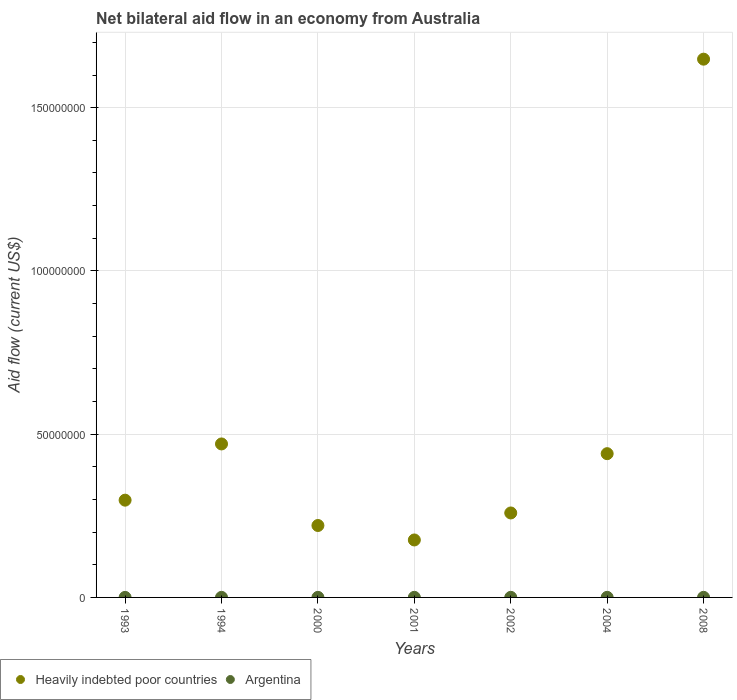How many different coloured dotlines are there?
Ensure brevity in your answer.  2. What is the net bilateral aid flow in Heavily indebted poor countries in 1993?
Provide a short and direct response. 2.98e+07. Across all years, what is the maximum net bilateral aid flow in Argentina?
Provide a short and direct response. 3.00e+04. Across all years, what is the minimum net bilateral aid flow in Heavily indebted poor countries?
Ensure brevity in your answer.  1.76e+07. In which year was the net bilateral aid flow in Argentina minimum?
Provide a short and direct response. 1993. What is the difference between the net bilateral aid flow in Argentina in 2002 and that in 2008?
Ensure brevity in your answer.  0. What is the difference between the net bilateral aid flow in Argentina in 1993 and the net bilateral aid flow in Heavily indebted poor countries in 2000?
Your response must be concise. -2.20e+07. What is the average net bilateral aid flow in Heavily indebted poor countries per year?
Keep it short and to the point. 5.02e+07. In the year 2002, what is the difference between the net bilateral aid flow in Argentina and net bilateral aid flow in Heavily indebted poor countries?
Your response must be concise. -2.58e+07. What is the ratio of the net bilateral aid flow in Heavily indebted poor countries in 2000 to that in 2001?
Make the answer very short. 1.25. Is the difference between the net bilateral aid flow in Argentina in 2000 and 2008 greater than the difference between the net bilateral aid flow in Heavily indebted poor countries in 2000 and 2008?
Offer a terse response. Yes. What is the difference between the highest and the second highest net bilateral aid flow in Heavily indebted poor countries?
Make the answer very short. 1.18e+08. What is the difference between the highest and the lowest net bilateral aid flow in Heavily indebted poor countries?
Ensure brevity in your answer.  1.47e+08. In how many years, is the net bilateral aid flow in Heavily indebted poor countries greater than the average net bilateral aid flow in Heavily indebted poor countries taken over all years?
Provide a short and direct response. 1. How many dotlines are there?
Give a very brief answer. 2. Does the graph contain any zero values?
Offer a very short reply. No. How many legend labels are there?
Provide a short and direct response. 2. How are the legend labels stacked?
Offer a terse response. Horizontal. What is the title of the graph?
Offer a terse response. Net bilateral aid flow in an economy from Australia. Does "Singapore" appear as one of the legend labels in the graph?
Your response must be concise. No. What is the Aid flow (current US$) of Heavily indebted poor countries in 1993?
Make the answer very short. 2.98e+07. What is the Aid flow (current US$) of Argentina in 1993?
Ensure brevity in your answer.  10000. What is the Aid flow (current US$) of Heavily indebted poor countries in 1994?
Give a very brief answer. 4.70e+07. What is the Aid flow (current US$) in Heavily indebted poor countries in 2000?
Provide a short and direct response. 2.20e+07. What is the Aid flow (current US$) of Argentina in 2000?
Offer a terse response. 2.00e+04. What is the Aid flow (current US$) of Heavily indebted poor countries in 2001?
Your answer should be compact. 1.76e+07. What is the Aid flow (current US$) of Heavily indebted poor countries in 2002?
Your answer should be very brief. 2.59e+07. What is the Aid flow (current US$) in Heavily indebted poor countries in 2004?
Make the answer very short. 4.40e+07. What is the Aid flow (current US$) in Heavily indebted poor countries in 2008?
Your answer should be very brief. 1.65e+08. Across all years, what is the maximum Aid flow (current US$) in Heavily indebted poor countries?
Your response must be concise. 1.65e+08. Across all years, what is the minimum Aid flow (current US$) in Heavily indebted poor countries?
Your answer should be compact. 1.76e+07. What is the total Aid flow (current US$) in Heavily indebted poor countries in the graph?
Make the answer very short. 3.51e+08. What is the total Aid flow (current US$) of Argentina in the graph?
Offer a terse response. 1.70e+05. What is the difference between the Aid flow (current US$) of Heavily indebted poor countries in 1993 and that in 1994?
Give a very brief answer. -1.72e+07. What is the difference between the Aid flow (current US$) in Heavily indebted poor countries in 1993 and that in 2000?
Keep it short and to the point. 7.76e+06. What is the difference between the Aid flow (current US$) in Heavily indebted poor countries in 1993 and that in 2001?
Make the answer very short. 1.22e+07. What is the difference between the Aid flow (current US$) of Heavily indebted poor countries in 1993 and that in 2002?
Provide a short and direct response. 3.92e+06. What is the difference between the Aid flow (current US$) in Heavily indebted poor countries in 1993 and that in 2004?
Offer a very short reply. -1.42e+07. What is the difference between the Aid flow (current US$) in Heavily indebted poor countries in 1993 and that in 2008?
Give a very brief answer. -1.35e+08. What is the difference between the Aid flow (current US$) in Heavily indebted poor countries in 1994 and that in 2000?
Your answer should be compact. 2.50e+07. What is the difference between the Aid flow (current US$) of Heavily indebted poor countries in 1994 and that in 2001?
Make the answer very short. 2.94e+07. What is the difference between the Aid flow (current US$) of Argentina in 1994 and that in 2001?
Offer a very short reply. -10000. What is the difference between the Aid flow (current US$) of Heavily indebted poor countries in 1994 and that in 2002?
Your answer should be very brief. 2.11e+07. What is the difference between the Aid flow (current US$) of Heavily indebted poor countries in 1994 and that in 2004?
Provide a short and direct response. 2.98e+06. What is the difference between the Aid flow (current US$) in Argentina in 1994 and that in 2004?
Make the answer very short. -10000. What is the difference between the Aid flow (current US$) in Heavily indebted poor countries in 1994 and that in 2008?
Your response must be concise. -1.18e+08. What is the difference between the Aid flow (current US$) of Heavily indebted poor countries in 2000 and that in 2001?
Ensure brevity in your answer.  4.43e+06. What is the difference between the Aid flow (current US$) in Heavily indebted poor countries in 2000 and that in 2002?
Ensure brevity in your answer.  -3.84e+06. What is the difference between the Aid flow (current US$) in Heavily indebted poor countries in 2000 and that in 2004?
Your response must be concise. -2.20e+07. What is the difference between the Aid flow (current US$) in Argentina in 2000 and that in 2004?
Offer a terse response. -10000. What is the difference between the Aid flow (current US$) in Heavily indebted poor countries in 2000 and that in 2008?
Make the answer very short. -1.43e+08. What is the difference between the Aid flow (current US$) of Argentina in 2000 and that in 2008?
Make the answer very short. -10000. What is the difference between the Aid flow (current US$) in Heavily indebted poor countries in 2001 and that in 2002?
Your response must be concise. -8.27e+06. What is the difference between the Aid flow (current US$) in Heavily indebted poor countries in 2001 and that in 2004?
Provide a succinct answer. -2.64e+07. What is the difference between the Aid flow (current US$) of Heavily indebted poor countries in 2001 and that in 2008?
Offer a very short reply. -1.47e+08. What is the difference between the Aid flow (current US$) in Argentina in 2001 and that in 2008?
Offer a terse response. 0. What is the difference between the Aid flow (current US$) in Heavily indebted poor countries in 2002 and that in 2004?
Your response must be concise. -1.82e+07. What is the difference between the Aid flow (current US$) in Heavily indebted poor countries in 2002 and that in 2008?
Make the answer very short. -1.39e+08. What is the difference between the Aid flow (current US$) of Argentina in 2002 and that in 2008?
Your answer should be very brief. 0. What is the difference between the Aid flow (current US$) in Heavily indebted poor countries in 2004 and that in 2008?
Offer a very short reply. -1.21e+08. What is the difference between the Aid flow (current US$) in Argentina in 2004 and that in 2008?
Your answer should be compact. 0. What is the difference between the Aid flow (current US$) in Heavily indebted poor countries in 1993 and the Aid flow (current US$) in Argentina in 1994?
Offer a terse response. 2.98e+07. What is the difference between the Aid flow (current US$) in Heavily indebted poor countries in 1993 and the Aid flow (current US$) in Argentina in 2000?
Keep it short and to the point. 2.98e+07. What is the difference between the Aid flow (current US$) of Heavily indebted poor countries in 1993 and the Aid flow (current US$) of Argentina in 2001?
Give a very brief answer. 2.98e+07. What is the difference between the Aid flow (current US$) of Heavily indebted poor countries in 1993 and the Aid flow (current US$) of Argentina in 2002?
Offer a very short reply. 2.98e+07. What is the difference between the Aid flow (current US$) of Heavily indebted poor countries in 1993 and the Aid flow (current US$) of Argentina in 2004?
Your answer should be compact. 2.98e+07. What is the difference between the Aid flow (current US$) of Heavily indebted poor countries in 1993 and the Aid flow (current US$) of Argentina in 2008?
Offer a very short reply. 2.98e+07. What is the difference between the Aid flow (current US$) of Heavily indebted poor countries in 1994 and the Aid flow (current US$) of Argentina in 2000?
Your answer should be very brief. 4.70e+07. What is the difference between the Aid flow (current US$) of Heavily indebted poor countries in 1994 and the Aid flow (current US$) of Argentina in 2001?
Give a very brief answer. 4.70e+07. What is the difference between the Aid flow (current US$) of Heavily indebted poor countries in 1994 and the Aid flow (current US$) of Argentina in 2002?
Give a very brief answer. 4.70e+07. What is the difference between the Aid flow (current US$) of Heavily indebted poor countries in 1994 and the Aid flow (current US$) of Argentina in 2004?
Ensure brevity in your answer.  4.70e+07. What is the difference between the Aid flow (current US$) of Heavily indebted poor countries in 1994 and the Aid flow (current US$) of Argentina in 2008?
Your answer should be compact. 4.70e+07. What is the difference between the Aid flow (current US$) of Heavily indebted poor countries in 2000 and the Aid flow (current US$) of Argentina in 2001?
Keep it short and to the point. 2.20e+07. What is the difference between the Aid flow (current US$) in Heavily indebted poor countries in 2000 and the Aid flow (current US$) in Argentina in 2002?
Give a very brief answer. 2.20e+07. What is the difference between the Aid flow (current US$) of Heavily indebted poor countries in 2000 and the Aid flow (current US$) of Argentina in 2004?
Provide a short and direct response. 2.20e+07. What is the difference between the Aid flow (current US$) in Heavily indebted poor countries in 2000 and the Aid flow (current US$) in Argentina in 2008?
Your response must be concise. 2.20e+07. What is the difference between the Aid flow (current US$) of Heavily indebted poor countries in 2001 and the Aid flow (current US$) of Argentina in 2002?
Provide a succinct answer. 1.76e+07. What is the difference between the Aid flow (current US$) in Heavily indebted poor countries in 2001 and the Aid flow (current US$) in Argentina in 2004?
Your response must be concise. 1.76e+07. What is the difference between the Aid flow (current US$) in Heavily indebted poor countries in 2001 and the Aid flow (current US$) in Argentina in 2008?
Provide a succinct answer. 1.76e+07. What is the difference between the Aid flow (current US$) in Heavily indebted poor countries in 2002 and the Aid flow (current US$) in Argentina in 2004?
Your answer should be compact. 2.58e+07. What is the difference between the Aid flow (current US$) of Heavily indebted poor countries in 2002 and the Aid flow (current US$) of Argentina in 2008?
Ensure brevity in your answer.  2.58e+07. What is the difference between the Aid flow (current US$) in Heavily indebted poor countries in 2004 and the Aid flow (current US$) in Argentina in 2008?
Offer a very short reply. 4.40e+07. What is the average Aid flow (current US$) in Heavily indebted poor countries per year?
Your answer should be very brief. 5.02e+07. What is the average Aid flow (current US$) of Argentina per year?
Your answer should be very brief. 2.43e+04. In the year 1993, what is the difference between the Aid flow (current US$) in Heavily indebted poor countries and Aid flow (current US$) in Argentina?
Make the answer very short. 2.98e+07. In the year 1994, what is the difference between the Aid flow (current US$) of Heavily indebted poor countries and Aid flow (current US$) of Argentina?
Give a very brief answer. 4.70e+07. In the year 2000, what is the difference between the Aid flow (current US$) in Heavily indebted poor countries and Aid flow (current US$) in Argentina?
Provide a succinct answer. 2.20e+07. In the year 2001, what is the difference between the Aid flow (current US$) of Heavily indebted poor countries and Aid flow (current US$) of Argentina?
Make the answer very short. 1.76e+07. In the year 2002, what is the difference between the Aid flow (current US$) in Heavily indebted poor countries and Aid flow (current US$) in Argentina?
Your answer should be very brief. 2.58e+07. In the year 2004, what is the difference between the Aid flow (current US$) of Heavily indebted poor countries and Aid flow (current US$) of Argentina?
Keep it short and to the point. 4.40e+07. In the year 2008, what is the difference between the Aid flow (current US$) of Heavily indebted poor countries and Aid flow (current US$) of Argentina?
Give a very brief answer. 1.65e+08. What is the ratio of the Aid flow (current US$) of Heavily indebted poor countries in 1993 to that in 1994?
Ensure brevity in your answer.  0.63. What is the ratio of the Aid flow (current US$) in Heavily indebted poor countries in 1993 to that in 2000?
Offer a very short reply. 1.35. What is the ratio of the Aid flow (current US$) in Heavily indebted poor countries in 1993 to that in 2001?
Provide a succinct answer. 1.69. What is the ratio of the Aid flow (current US$) of Argentina in 1993 to that in 2001?
Make the answer very short. 0.33. What is the ratio of the Aid flow (current US$) in Heavily indebted poor countries in 1993 to that in 2002?
Make the answer very short. 1.15. What is the ratio of the Aid flow (current US$) of Heavily indebted poor countries in 1993 to that in 2004?
Ensure brevity in your answer.  0.68. What is the ratio of the Aid flow (current US$) of Argentina in 1993 to that in 2004?
Offer a very short reply. 0.33. What is the ratio of the Aid flow (current US$) of Heavily indebted poor countries in 1993 to that in 2008?
Give a very brief answer. 0.18. What is the ratio of the Aid flow (current US$) in Argentina in 1993 to that in 2008?
Provide a short and direct response. 0.33. What is the ratio of the Aid flow (current US$) in Heavily indebted poor countries in 1994 to that in 2000?
Offer a very short reply. 2.13. What is the ratio of the Aid flow (current US$) of Heavily indebted poor countries in 1994 to that in 2001?
Keep it short and to the point. 2.67. What is the ratio of the Aid flow (current US$) in Heavily indebted poor countries in 1994 to that in 2002?
Provide a succinct answer. 1.82. What is the ratio of the Aid flow (current US$) in Argentina in 1994 to that in 2002?
Make the answer very short. 0.67. What is the ratio of the Aid flow (current US$) in Heavily indebted poor countries in 1994 to that in 2004?
Give a very brief answer. 1.07. What is the ratio of the Aid flow (current US$) in Heavily indebted poor countries in 1994 to that in 2008?
Offer a terse response. 0.29. What is the ratio of the Aid flow (current US$) in Heavily indebted poor countries in 2000 to that in 2001?
Offer a terse response. 1.25. What is the ratio of the Aid flow (current US$) in Argentina in 2000 to that in 2001?
Your answer should be compact. 0.67. What is the ratio of the Aid flow (current US$) of Heavily indebted poor countries in 2000 to that in 2002?
Give a very brief answer. 0.85. What is the ratio of the Aid flow (current US$) of Heavily indebted poor countries in 2000 to that in 2004?
Give a very brief answer. 0.5. What is the ratio of the Aid flow (current US$) of Argentina in 2000 to that in 2004?
Give a very brief answer. 0.67. What is the ratio of the Aid flow (current US$) in Heavily indebted poor countries in 2000 to that in 2008?
Ensure brevity in your answer.  0.13. What is the ratio of the Aid flow (current US$) of Argentina in 2000 to that in 2008?
Make the answer very short. 0.67. What is the ratio of the Aid flow (current US$) of Heavily indebted poor countries in 2001 to that in 2002?
Provide a short and direct response. 0.68. What is the ratio of the Aid flow (current US$) of Heavily indebted poor countries in 2001 to that in 2004?
Your response must be concise. 0.4. What is the ratio of the Aid flow (current US$) of Argentina in 2001 to that in 2004?
Keep it short and to the point. 1. What is the ratio of the Aid flow (current US$) in Heavily indebted poor countries in 2001 to that in 2008?
Ensure brevity in your answer.  0.11. What is the ratio of the Aid flow (current US$) of Argentina in 2001 to that in 2008?
Your answer should be very brief. 1. What is the ratio of the Aid flow (current US$) in Heavily indebted poor countries in 2002 to that in 2004?
Offer a very short reply. 0.59. What is the ratio of the Aid flow (current US$) of Argentina in 2002 to that in 2004?
Offer a very short reply. 1. What is the ratio of the Aid flow (current US$) in Heavily indebted poor countries in 2002 to that in 2008?
Offer a very short reply. 0.16. What is the ratio of the Aid flow (current US$) of Argentina in 2002 to that in 2008?
Ensure brevity in your answer.  1. What is the ratio of the Aid flow (current US$) in Heavily indebted poor countries in 2004 to that in 2008?
Provide a succinct answer. 0.27. What is the difference between the highest and the second highest Aid flow (current US$) in Heavily indebted poor countries?
Ensure brevity in your answer.  1.18e+08. What is the difference between the highest and the second highest Aid flow (current US$) in Argentina?
Keep it short and to the point. 0. What is the difference between the highest and the lowest Aid flow (current US$) of Heavily indebted poor countries?
Give a very brief answer. 1.47e+08. What is the difference between the highest and the lowest Aid flow (current US$) of Argentina?
Provide a succinct answer. 2.00e+04. 